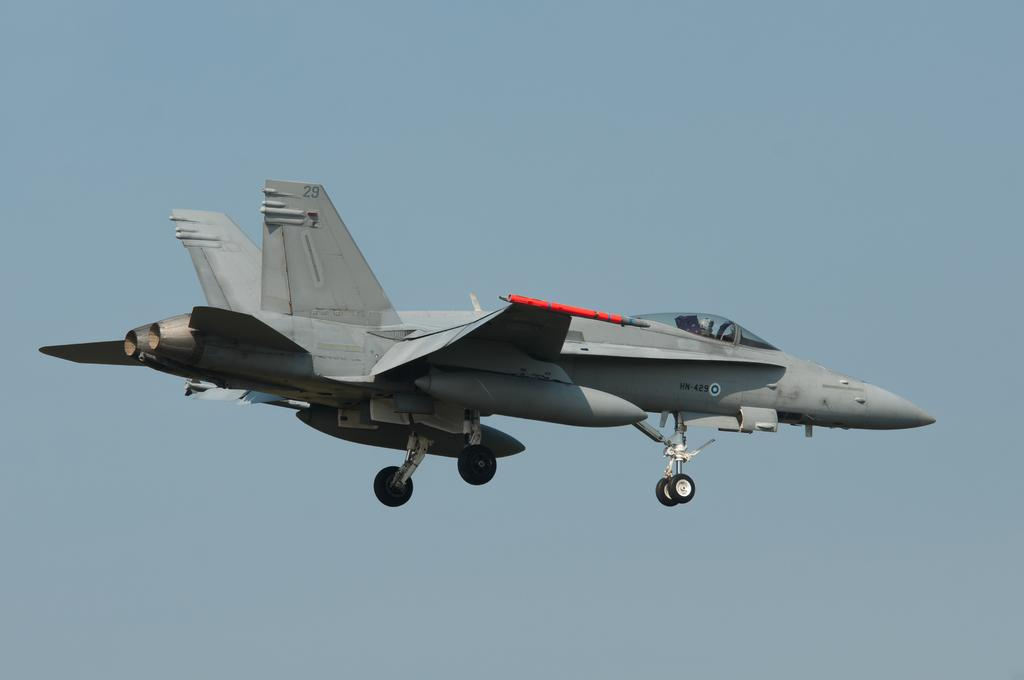What is the main subject of the picture? The main subject of the picture is an airplane. Where is the airplane located in the image? The airplane is at the center of the image. What can be seen in the background of the image? The sky is visible in the background of the image. What type of stew is being served on the airplane in the image? There is no indication of food or stew being served on the airplane in the image. Can you describe the texture of the airplane's exterior in the image? The provided facts do not include any information about the texture of the airplane's exterior. 